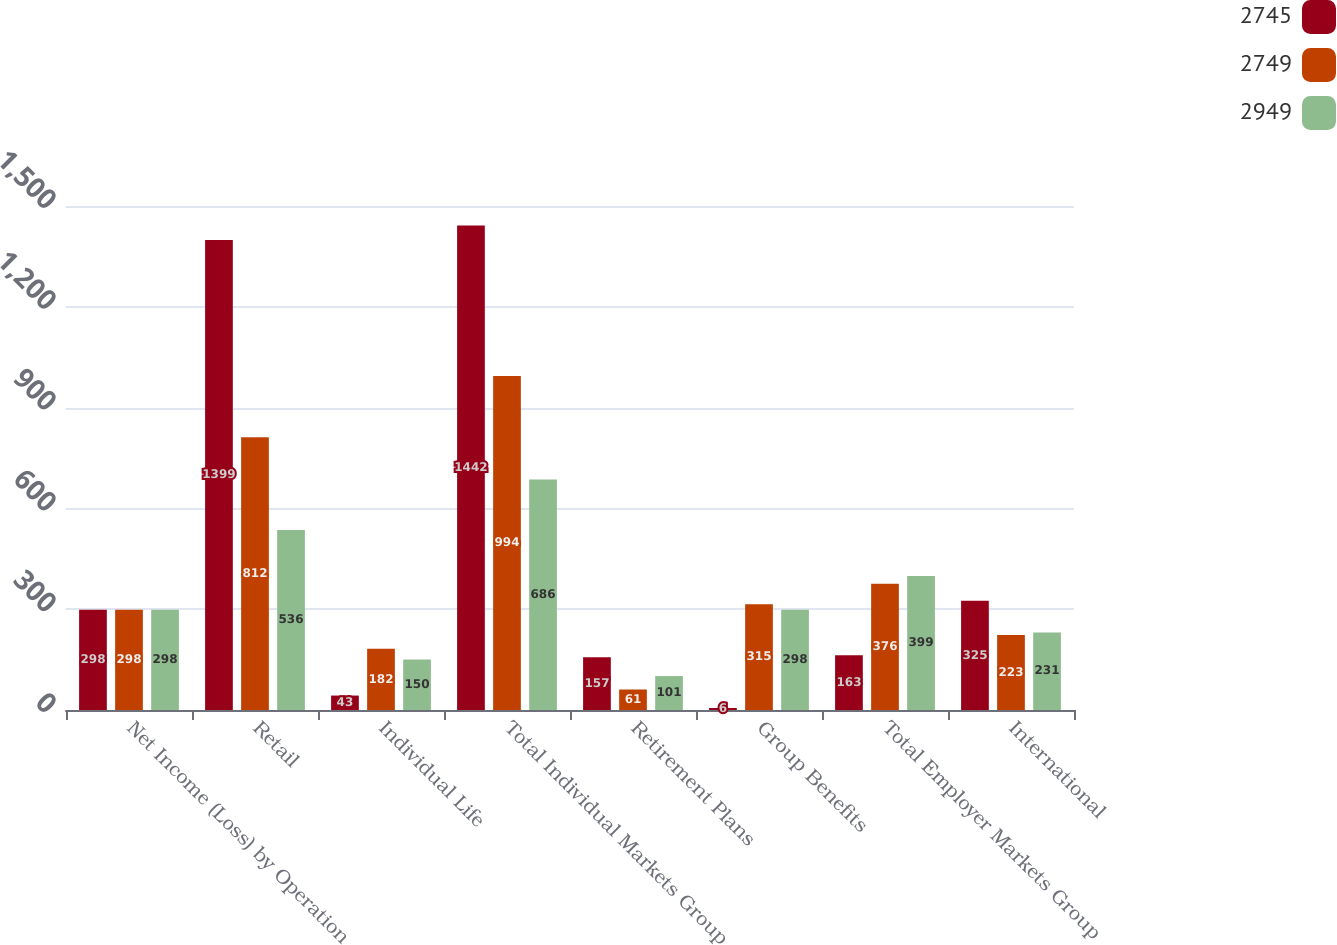<chart> <loc_0><loc_0><loc_500><loc_500><stacked_bar_chart><ecel><fcel>Net Income (Loss) by Operation<fcel>Retail<fcel>Individual Life<fcel>Total Individual Markets Group<fcel>Retirement Plans<fcel>Group Benefits<fcel>Total Employer Markets Group<fcel>International<nl><fcel>2745<fcel>298<fcel>1399<fcel>43<fcel>1442<fcel>157<fcel>6<fcel>163<fcel>325<nl><fcel>2749<fcel>298<fcel>812<fcel>182<fcel>994<fcel>61<fcel>315<fcel>376<fcel>223<nl><fcel>2949<fcel>298<fcel>536<fcel>150<fcel>686<fcel>101<fcel>298<fcel>399<fcel>231<nl></chart> 